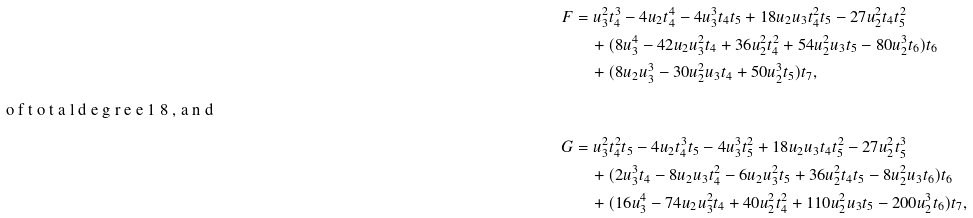Convert formula to latex. <formula><loc_0><loc_0><loc_500><loc_500>F & = u _ { 3 } ^ { 2 } t _ { 4 } ^ { 3 } - 4 u _ { 2 } t _ { 4 } ^ { 4 } - 4 u _ { 3 } ^ { 3 } t _ { 4 } t _ { 5 } + 1 8 u _ { 2 } u _ { 3 } t _ { 4 } ^ { 2 } t _ { 5 } - 2 7 u _ { 2 } ^ { 2 } t _ { 4 } t _ { 5 } ^ { 2 } \\ & \quad + ( 8 u _ { 3 } ^ { 4 } - 4 2 u _ { 2 } u _ { 3 } ^ { 2 } t _ { 4 } + 3 6 u _ { 2 } ^ { 2 } t _ { 4 } ^ { 2 } + 5 4 u _ { 2 } ^ { 2 } u _ { 3 } t _ { 5 } - 8 0 u _ { 2 } ^ { 3 } t _ { 6 } ) t _ { 6 } \\ & \quad + ( 8 u _ { 2 } u _ { 3 } ^ { 3 } - 3 0 u _ { 2 } ^ { 2 } u _ { 3 } t _ { 4 } + 5 0 u _ { 2 } ^ { 3 } t _ { 5 } ) t _ { 7 } , \\ \intertext { o f t o t a l d e g r e e 1 8 , a n d } G & = u _ { 3 } ^ { 2 } t _ { 4 } ^ { 2 } t _ { 5 } - 4 u _ { 2 } t _ { 4 } ^ { 3 } t _ { 5 } - 4 u _ { 3 } ^ { 3 } t _ { 5 } ^ { 2 } + 1 8 u _ { 2 } u _ { 3 } t _ { 4 } t _ { 5 } ^ { 2 } - 2 7 u _ { 2 } ^ { 2 } t _ { 5 } ^ { 3 } \\ & \quad + ( 2 u _ { 3 } ^ { 3 } t _ { 4 } - 8 u _ { 2 } u _ { 3 } t _ { 4 } ^ { 2 } - 6 u _ { 2 } u _ { 3 } ^ { 2 } t _ { 5 } + 3 6 u _ { 2 } ^ { 2 } t _ { 4 } t _ { 5 } - 8 u _ { 2 } ^ { 2 } u _ { 3 } t _ { 6 } ) t _ { 6 } \\ & \quad + ( 1 6 u _ { 3 } ^ { 4 } - 7 4 u _ { 2 } u _ { 3 } ^ { 2 } t _ { 4 } + 4 0 u _ { 2 } ^ { 2 } t _ { 4 } ^ { 2 } + 1 1 0 u _ { 2 } ^ { 2 } u _ { 3 } t _ { 5 } - 2 0 0 u _ { 2 } ^ { 3 } t _ { 6 } ) t _ { 7 } ,</formula> 